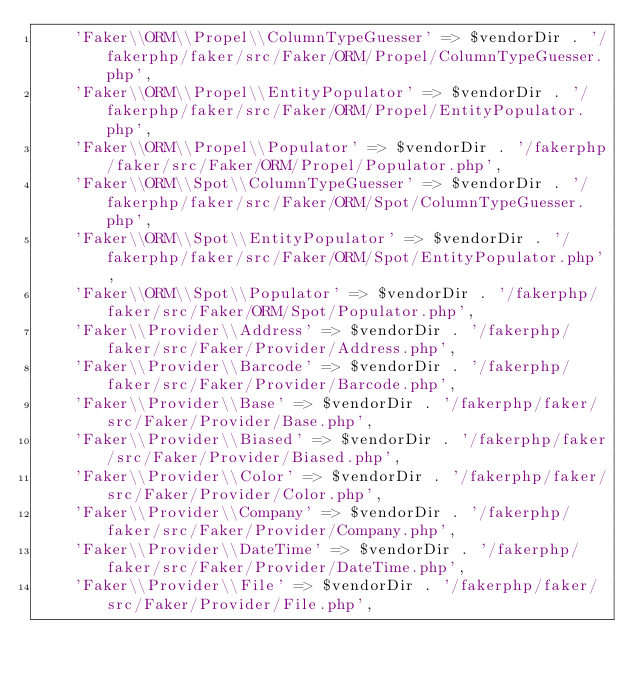Convert code to text. <code><loc_0><loc_0><loc_500><loc_500><_PHP_>    'Faker\\ORM\\Propel\\ColumnTypeGuesser' => $vendorDir . '/fakerphp/faker/src/Faker/ORM/Propel/ColumnTypeGuesser.php',
    'Faker\\ORM\\Propel\\EntityPopulator' => $vendorDir . '/fakerphp/faker/src/Faker/ORM/Propel/EntityPopulator.php',
    'Faker\\ORM\\Propel\\Populator' => $vendorDir . '/fakerphp/faker/src/Faker/ORM/Propel/Populator.php',
    'Faker\\ORM\\Spot\\ColumnTypeGuesser' => $vendorDir . '/fakerphp/faker/src/Faker/ORM/Spot/ColumnTypeGuesser.php',
    'Faker\\ORM\\Spot\\EntityPopulator' => $vendorDir . '/fakerphp/faker/src/Faker/ORM/Spot/EntityPopulator.php',
    'Faker\\ORM\\Spot\\Populator' => $vendorDir . '/fakerphp/faker/src/Faker/ORM/Spot/Populator.php',
    'Faker\\Provider\\Address' => $vendorDir . '/fakerphp/faker/src/Faker/Provider/Address.php',
    'Faker\\Provider\\Barcode' => $vendorDir . '/fakerphp/faker/src/Faker/Provider/Barcode.php',
    'Faker\\Provider\\Base' => $vendorDir . '/fakerphp/faker/src/Faker/Provider/Base.php',
    'Faker\\Provider\\Biased' => $vendorDir . '/fakerphp/faker/src/Faker/Provider/Biased.php',
    'Faker\\Provider\\Color' => $vendorDir . '/fakerphp/faker/src/Faker/Provider/Color.php',
    'Faker\\Provider\\Company' => $vendorDir . '/fakerphp/faker/src/Faker/Provider/Company.php',
    'Faker\\Provider\\DateTime' => $vendorDir . '/fakerphp/faker/src/Faker/Provider/DateTime.php',
    'Faker\\Provider\\File' => $vendorDir . '/fakerphp/faker/src/Faker/Provider/File.php',</code> 